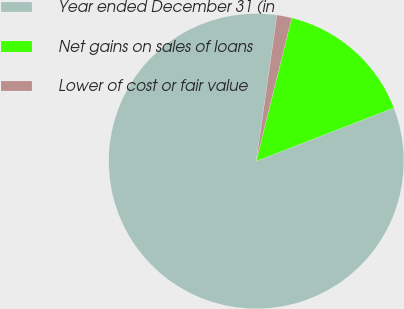Convert chart. <chart><loc_0><loc_0><loc_500><loc_500><pie_chart><fcel>Year ended December 31 (in<fcel>Net gains on sales of loans<fcel>Lower of cost or fair value<nl><fcel>83.12%<fcel>15.26%<fcel>1.62%<nl></chart> 